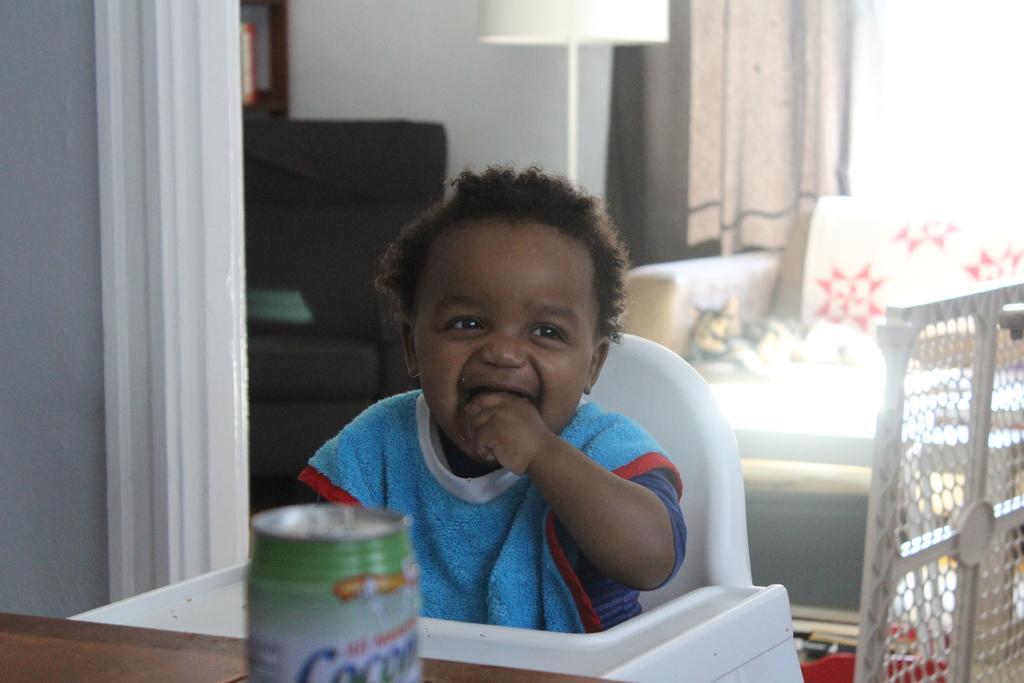Could you give a brief overview of what you see in this image? This is a small boy sitting in the chair. This looks like a tin, which is placed on the wooden table. I think this is a kind of a fencing sheet. I can see a cat, sitting on the couch. Here is a lamp, which is white in color. This looks like a curtain, which is hanging. I think this is a chair. 